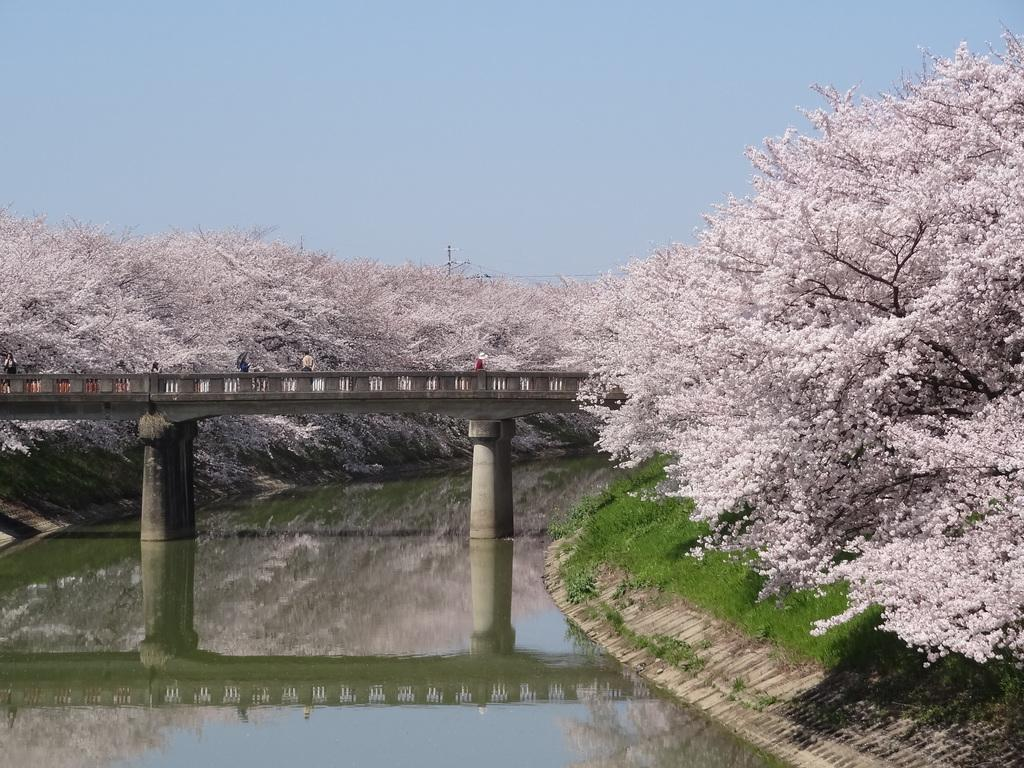What type of vegetation can be seen in the image? There are flowers, trees, and grass in the image. What structure is present in the image? There is a bridge in the image. Where is the bridge located in relation to other elements in the image? The bridge is positioned over water. What type of eggnog can be seen in the image? There is no eggnog present in the image. What time of day is depicted in the image? The time of day cannot be determined from the image alone, as there are no specific indicators of time. 